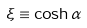Convert formula to latex. <formula><loc_0><loc_0><loc_500><loc_500>\xi \equiv \cosh \alpha</formula> 